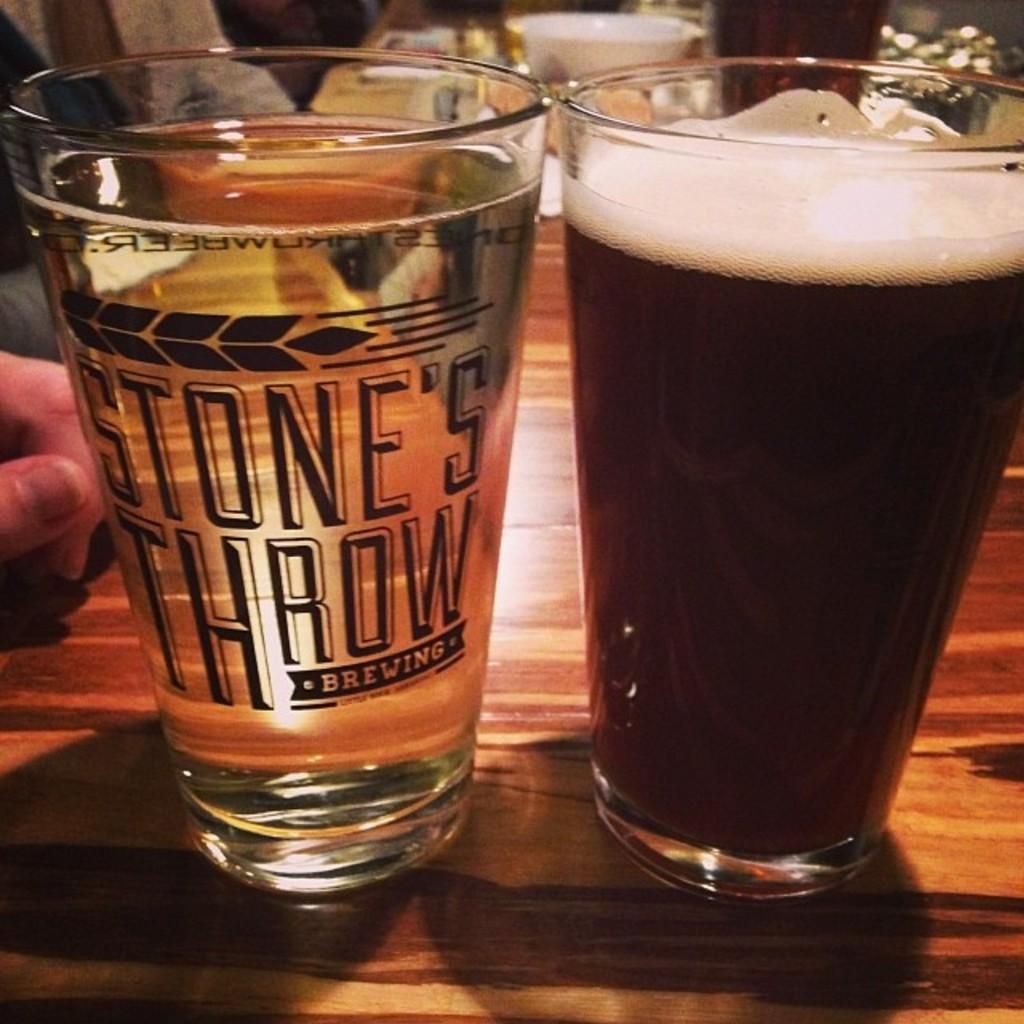In one or two sentences, can you explain what this image depicts? In this picture I can see the brown color surface on which there are 2 glasses and I see liquid in those glasses and on the left glass I can see few words written and on the left side of this image I can see the fingers of a person and it is a bit blurred in the background. 